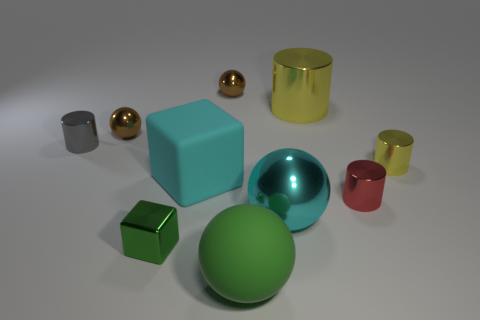Subtract all small red shiny cylinders. How many cylinders are left? 3 Subtract all brown spheres. How many spheres are left? 2 Subtract 2 cylinders. How many cylinders are left? 2 Subtract all balls. How many objects are left? 6 Add 7 tiny green blocks. How many tiny green blocks are left? 8 Add 2 small green metal objects. How many small green metal objects exist? 3 Subtract 0 blue cubes. How many objects are left? 10 Subtract all red balls. Subtract all yellow cubes. How many balls are left? 4 Subtract all cyan spheres. How many cyan cubes are left? 1 Subtract all green blocks. Subtract all big cyan metal objects. How many objects are left? 8 